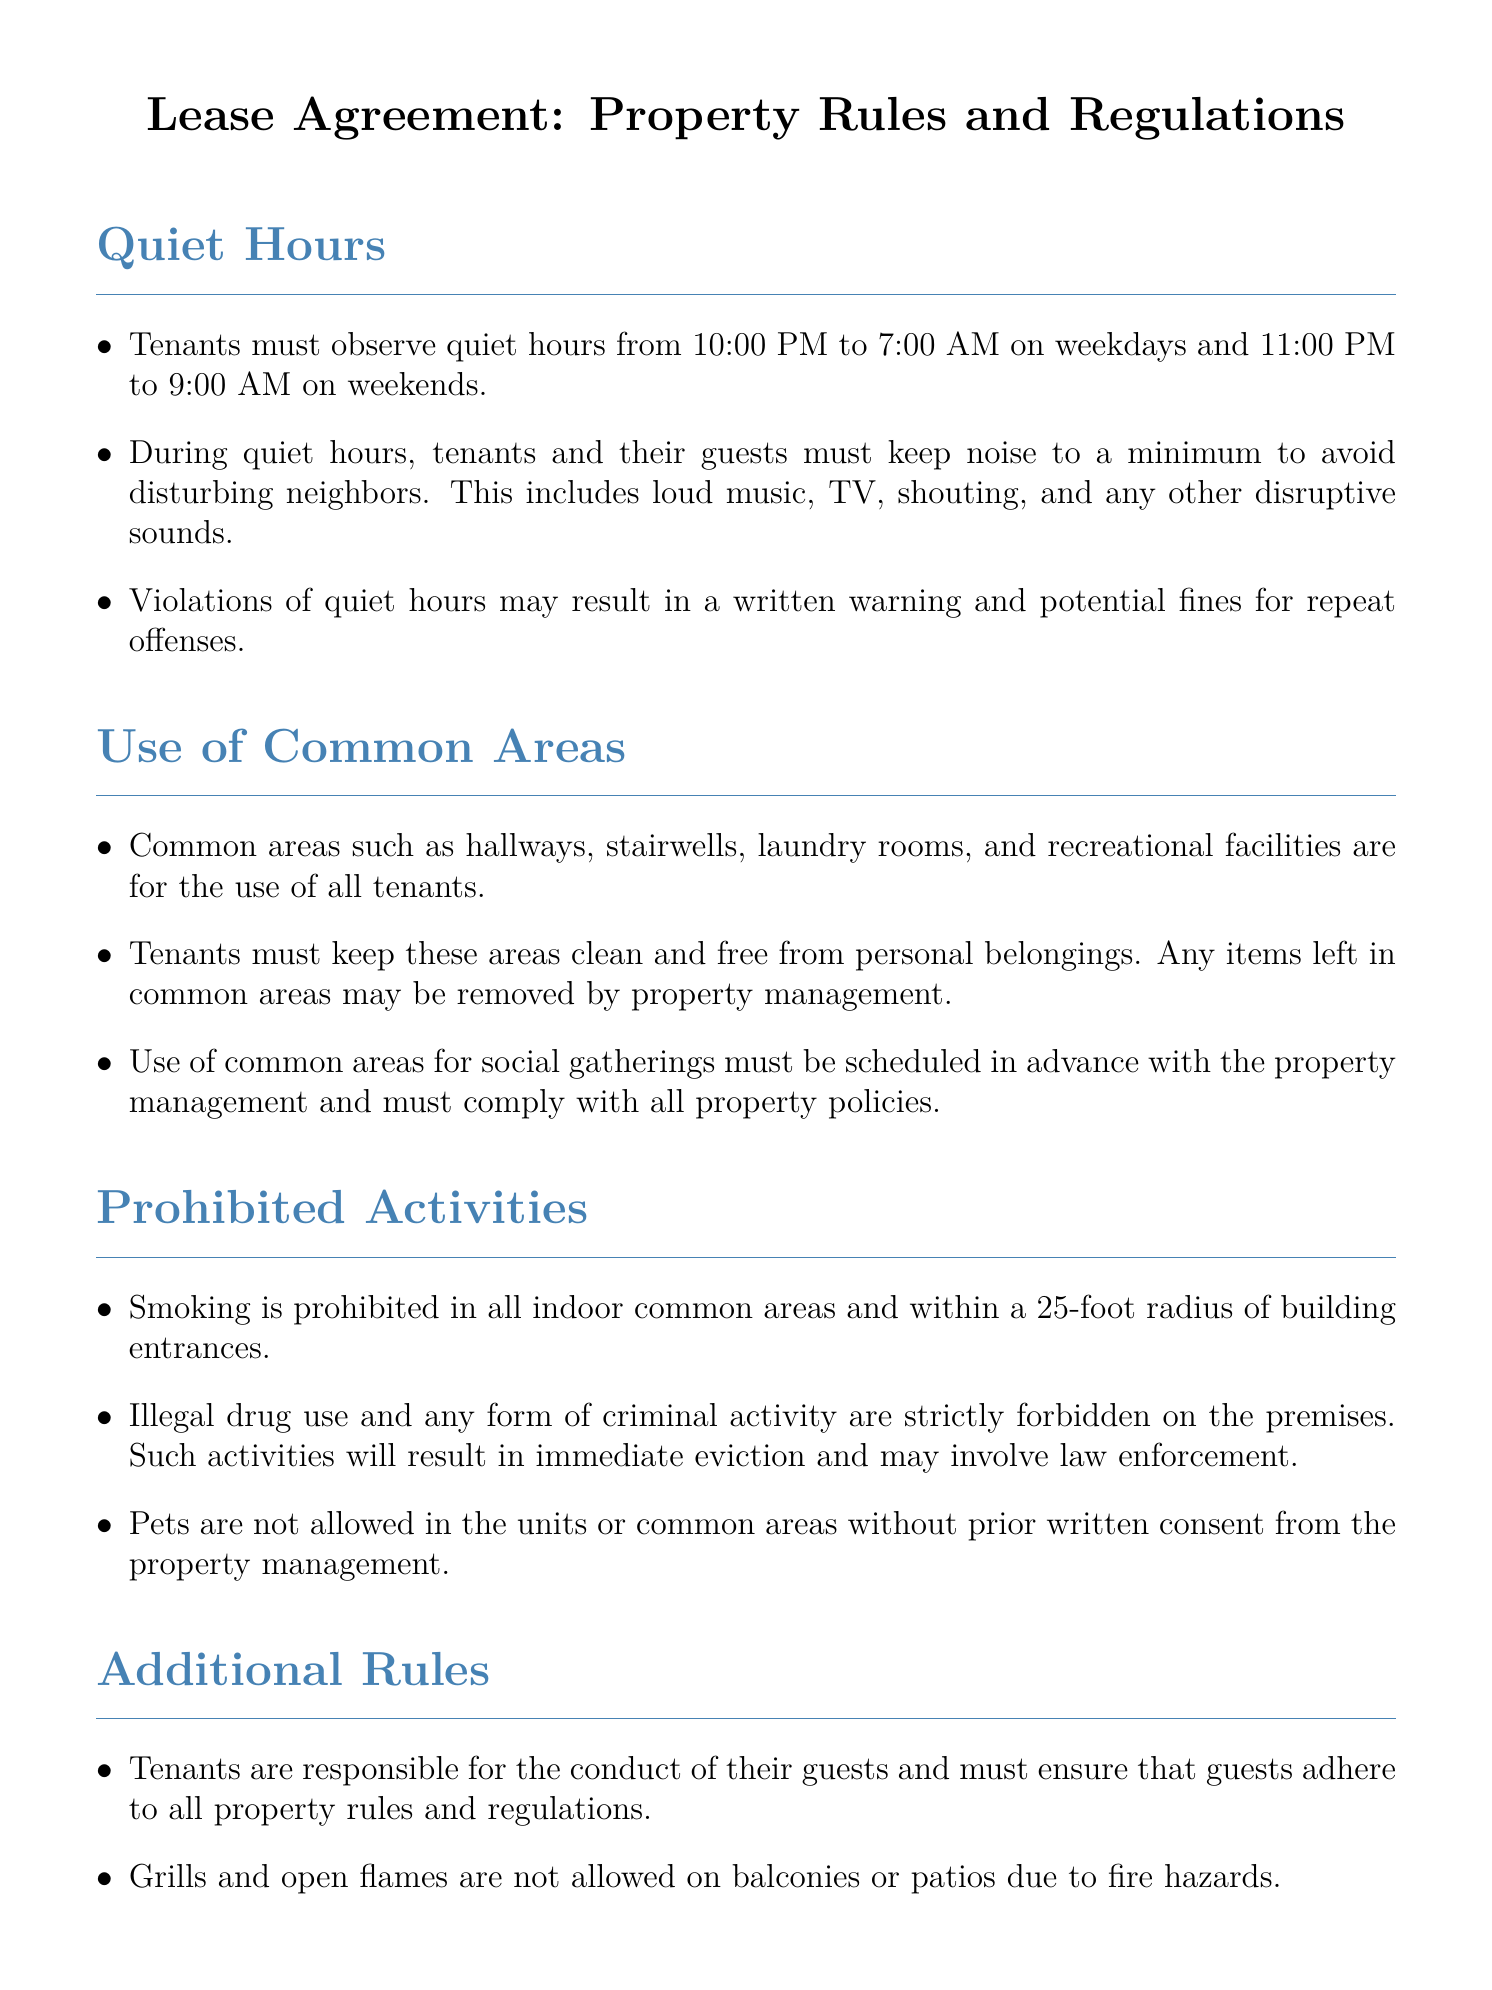What are the quiet hours on weekdays? Quiet hours for weekdays are defined as the times during which tenants must keep noise to a minimum, specifically between 10:00 PM and 7:00 AM.
Answer: 10:00 PM to 7:00 AM What are the weekend quiet hours? The document specifies distinct quiet hours for weekends, which are later than weekdays, therefore requiring awareness from the tenants.
Answer: 11:00 PM to 9:00 AM What activities are strictly forbidden on the premises? The document lists illegal drug use and any form of criminal activity as strictly forbidden, signifying the property's stance on illegal behavior.
Answer: Illegal drug use and any form of criminal activity Who must schedule the use of common areas for social gatherings? Tenants are required to coordinate with property management which is a key aspect of maintaining the rules related to common areas.
Answer: Property management What is prohibited within a 25-foot radius of building entrances? The document details smoking restrictions specifically around the entrances, clarifying where smoking is not allowed.
Answer: Smoking What must be done with items left in common areas? The document outlines specific actions to be taken regarding items left in common areas, indicating tenant responsibilities for communal spaces.
Answer: Removed by property management What is required for tenants to have pets in the units? Pet ownership within the units comes with stipulations that must be followed according to the lease agreement, highlighting tenant obligations.
Answer: Prior written consent What must be adhered to by tenants regarding their guests? The responsibility of tenant conduct extends to their guests, emphasizing the collective adherence to the property’s rules.
Answer: All property rules and regulations 